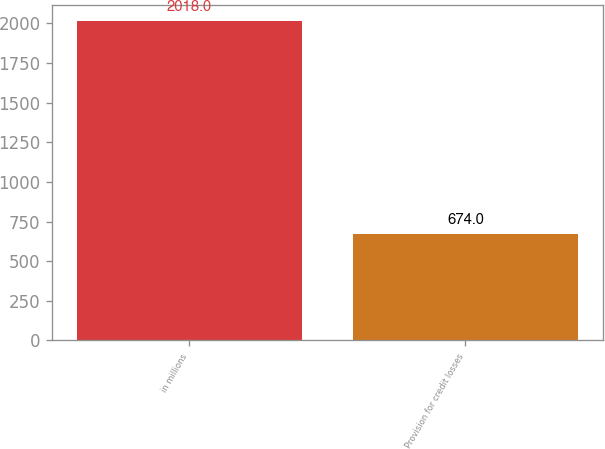Convert chart. <chart><loc_0><loc_0><loc_500><loc_500><bar_chart><fcel>in millions<fcel>Provision for credit losses<nl><fcel>2018<fcel>674<nl></chart> 